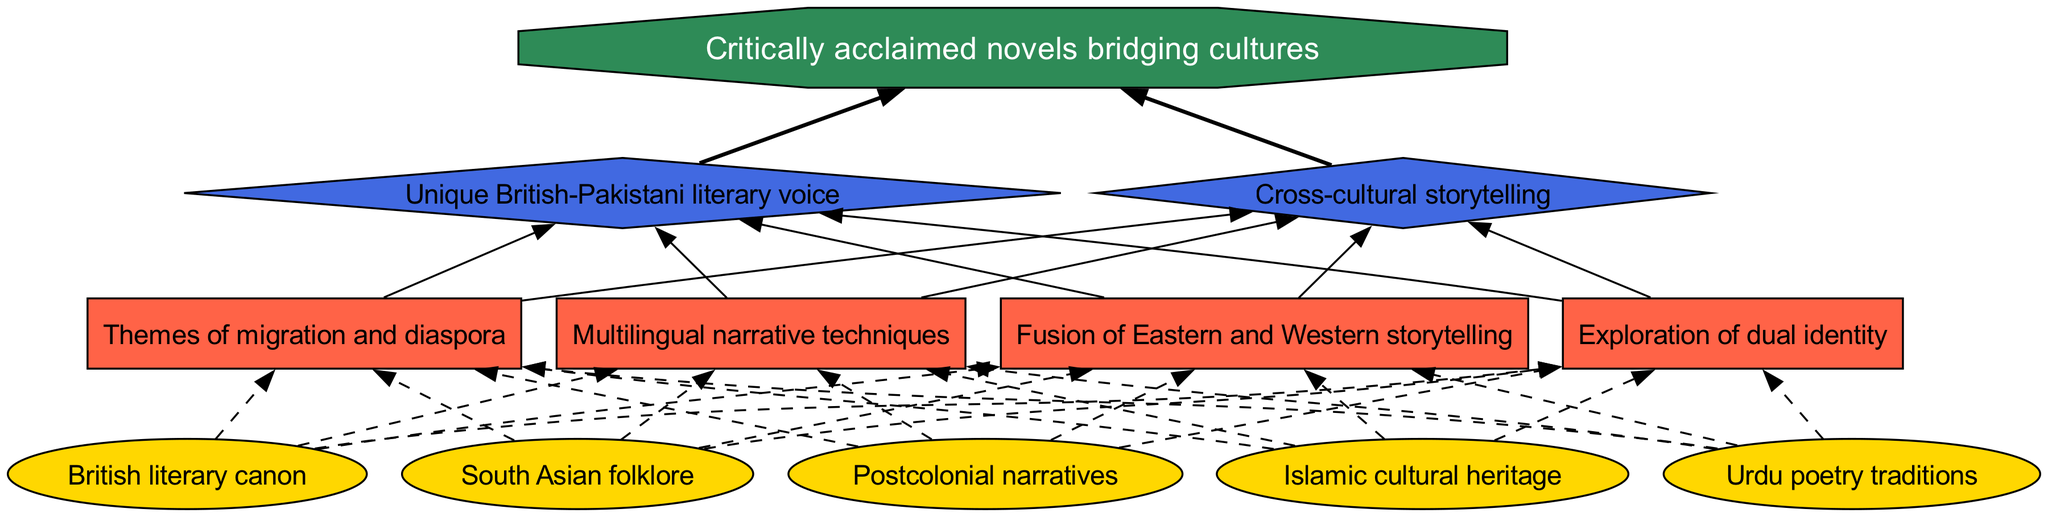What are the bottom-level influences? The bottom-level influences shaping a British-Pakistani novelist's work include Urdu poetry traditions, British literary canon, South Asian folklore, Postcolonial narratives, and Islamic cultural heritage. These elements are directly mentioned in the bottom level of the diagram.
Answer: Urdu poetry traditions, British literary canon, South Asian folklore, Postcolonial narratives, Islamic cultural heritage How many mid-level influences are there? To find the number of mid-level influences, we count the elements listed in the mid-level of the diagram, which are four: Fusion of Eastern and Western storytelling, Exploration of dual identity, Themes of migration and diaspora, and Multilingual narrative techniques.
Answer: 4 What is the title of the top-level influence? The top-level influences include Unique British-Pakistani literary voice and Cross-cultural storytelling. Both titles are directly stated in the top level of the diagram.
Answer: Unique British-Pakistani literary voice, Cross-cultural storytelling Which influence connects British literary canon and themes of migration? To determine the influence connecting British literary canon and themes of migration, we look at the flow from 'British literary canon' in the bottom level to 'Themes of migration and diaspora' in the mid-level. This connection is established through the shared mid-level influence that encompasses aspects of both.
Answer: Themes of migration and diaspora What final output results from the influences depicted in the diagram? The final output is critically acclaimed novels bridging cultures, depicted as the endpoint of the flowchart, consolidating the influences explored throughout the diagram.
Answer: Critically acclaimed novels bridging cultures How many edges connect bottom-level influences to mid-level influences? Each bottom-level influence has the potential to connect to every mid-level influence. With five bottom-level influences and four mid-level influences, we calculate the total edges as 5 (bottom) x 4 (mid) = 20 edges. This reflects the multiple connections in the diagram.
Answer: 20 Which mid-level influence focuses on identity? The mid-level influence that specifically addresses identity is Exploration of dual identity, selected explicitly from the mid-level influences listed in the diagram.
Answer: Exploration of dual identity How is the top level influenced by the mid-level? The top level is influenced by both mid-level influences, which suggest the synthesis of diverse narrative elements into a unique literary voice, illustrating how cultural influences combine to create a richer storytelling experience. Thus, the reasoning connects all mid-level aspects to shape the top level.
Answer: Unique British-Pakistani literary voice, Cross-cultural storytelling 